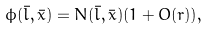Convert formula to latex. <formula><loc_0><loc_0><loc_500><loc_500>\phi ( \bar { l } , \bar { x } ) = N ( \bar { l } , \bar { x } ) ( 1 + O ( r ) ) ,</formula> 